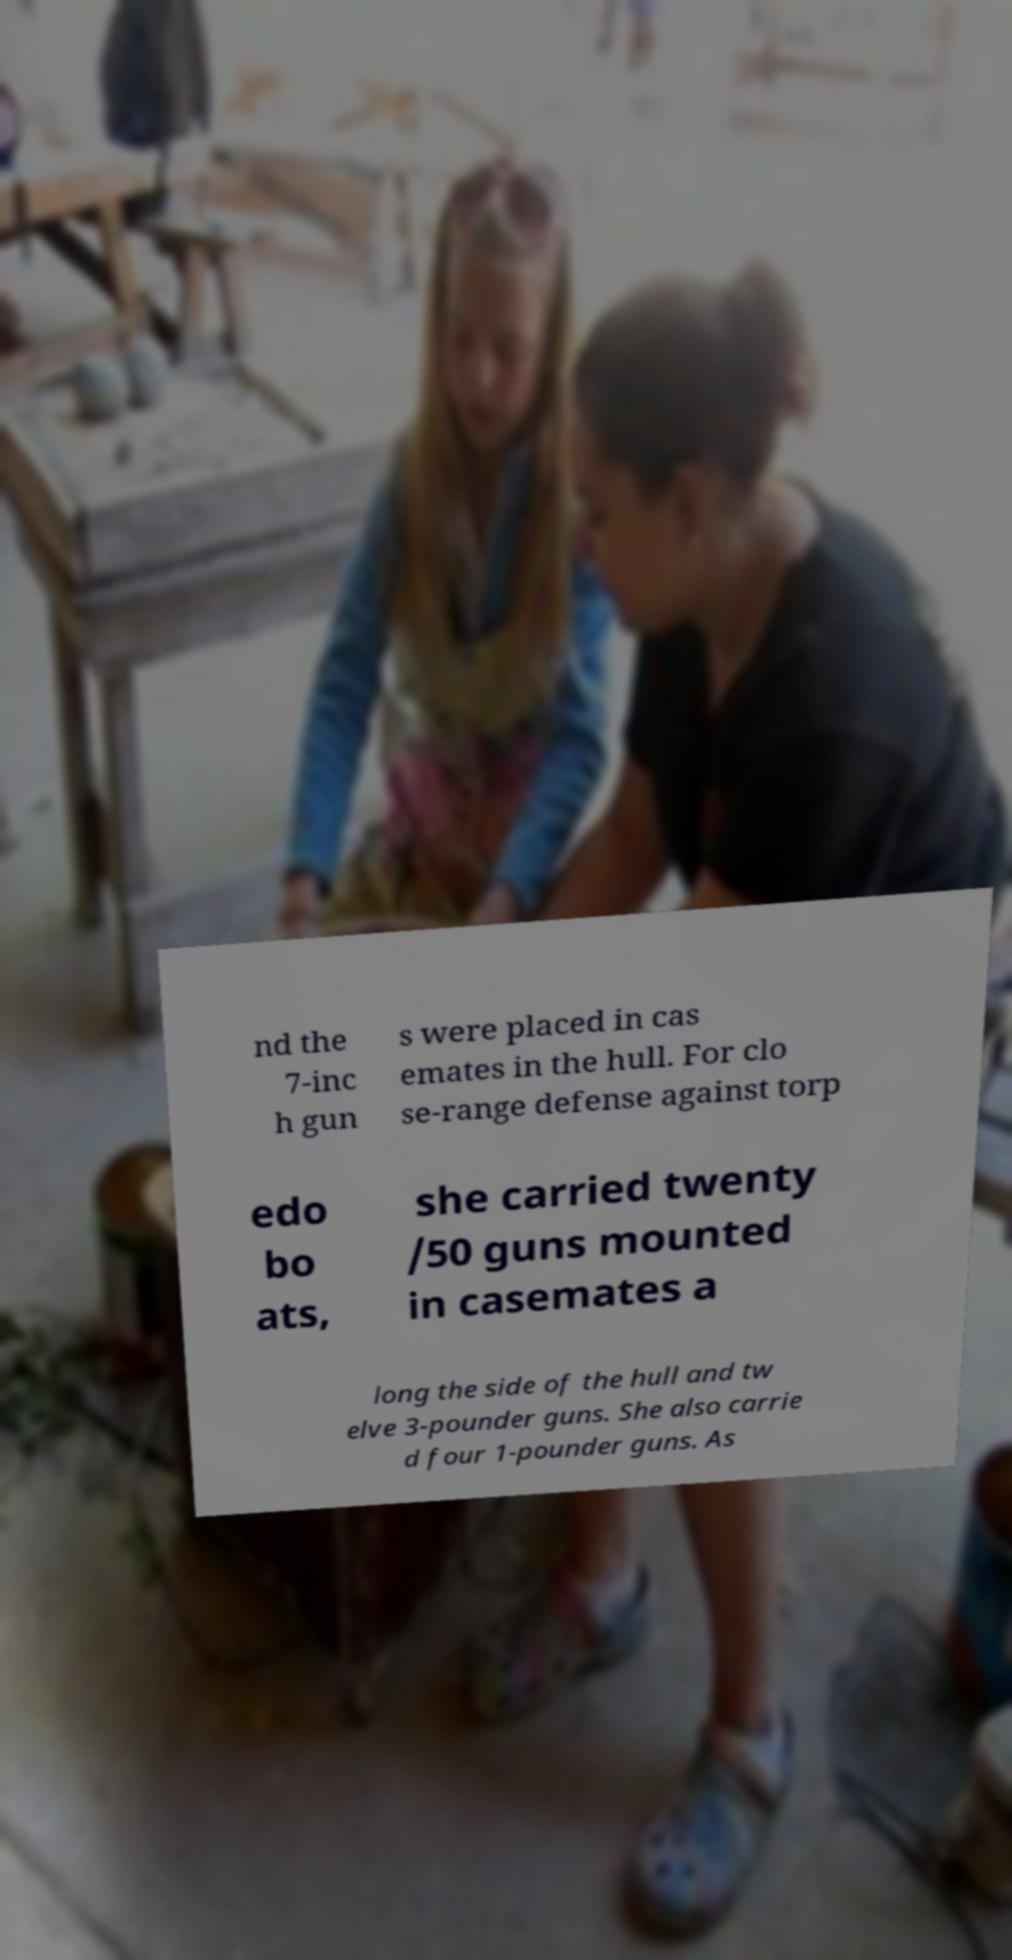Please identify and transcribe the text found in this image. nd the 7-inc h gun s were placed in cas emates in the hull. For clo se-range defense against torp edo bo ats, she carried twenty /50 guns mounted in casemates a long the side of the hull and tw elve 3-pounder guns. She also carrie d four 1-pounder guns. As 